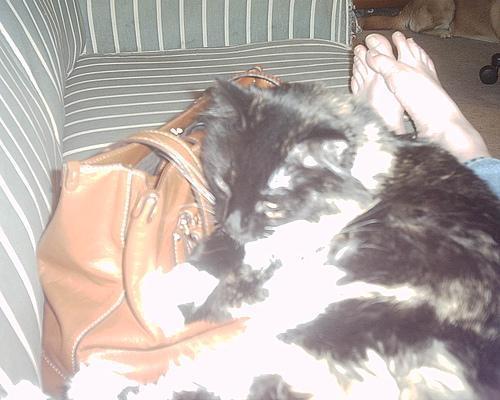How many people are visible?
Give a very brief answer. 1. How many giraffes are leaning over the woman's left shoulder?
Give a very brief answer. 0. 